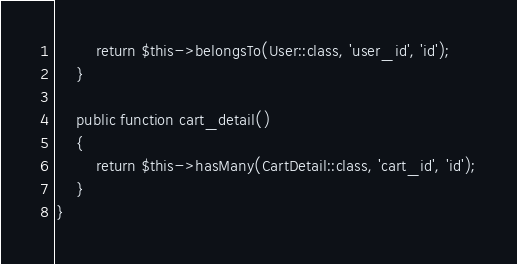<code> <loc_0><loc_0><loc_500><loc_500><_PHP_>        return $this->belongsTo(User::class, 'user_id', 'id');
    }

    public function cart_detail()
    {
        return $this->hasMany(CartDetail::class, 'cart_id', 'id');
    }
}</code> 